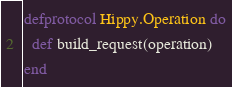Convert code to text. <code><loc_0><loc_0><loc_500><loc_500><_Elixir_>defprotocol Hippy.Operation do
  def build_request(operation)
end
</code> 